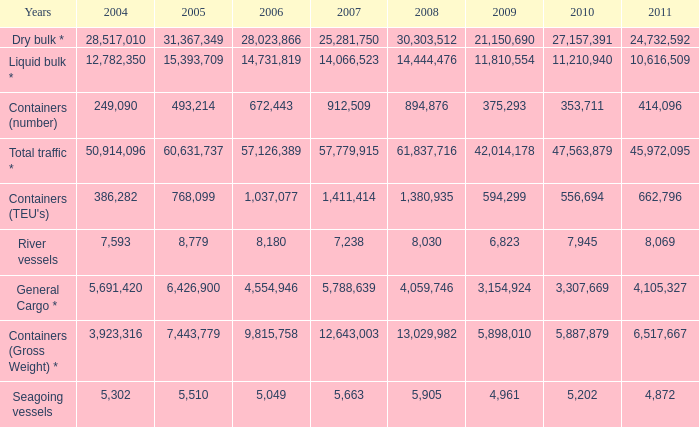What is the highest value in 2011 with less than 5,049 in 2006 and less than 1,380,935 in 2008? None. 